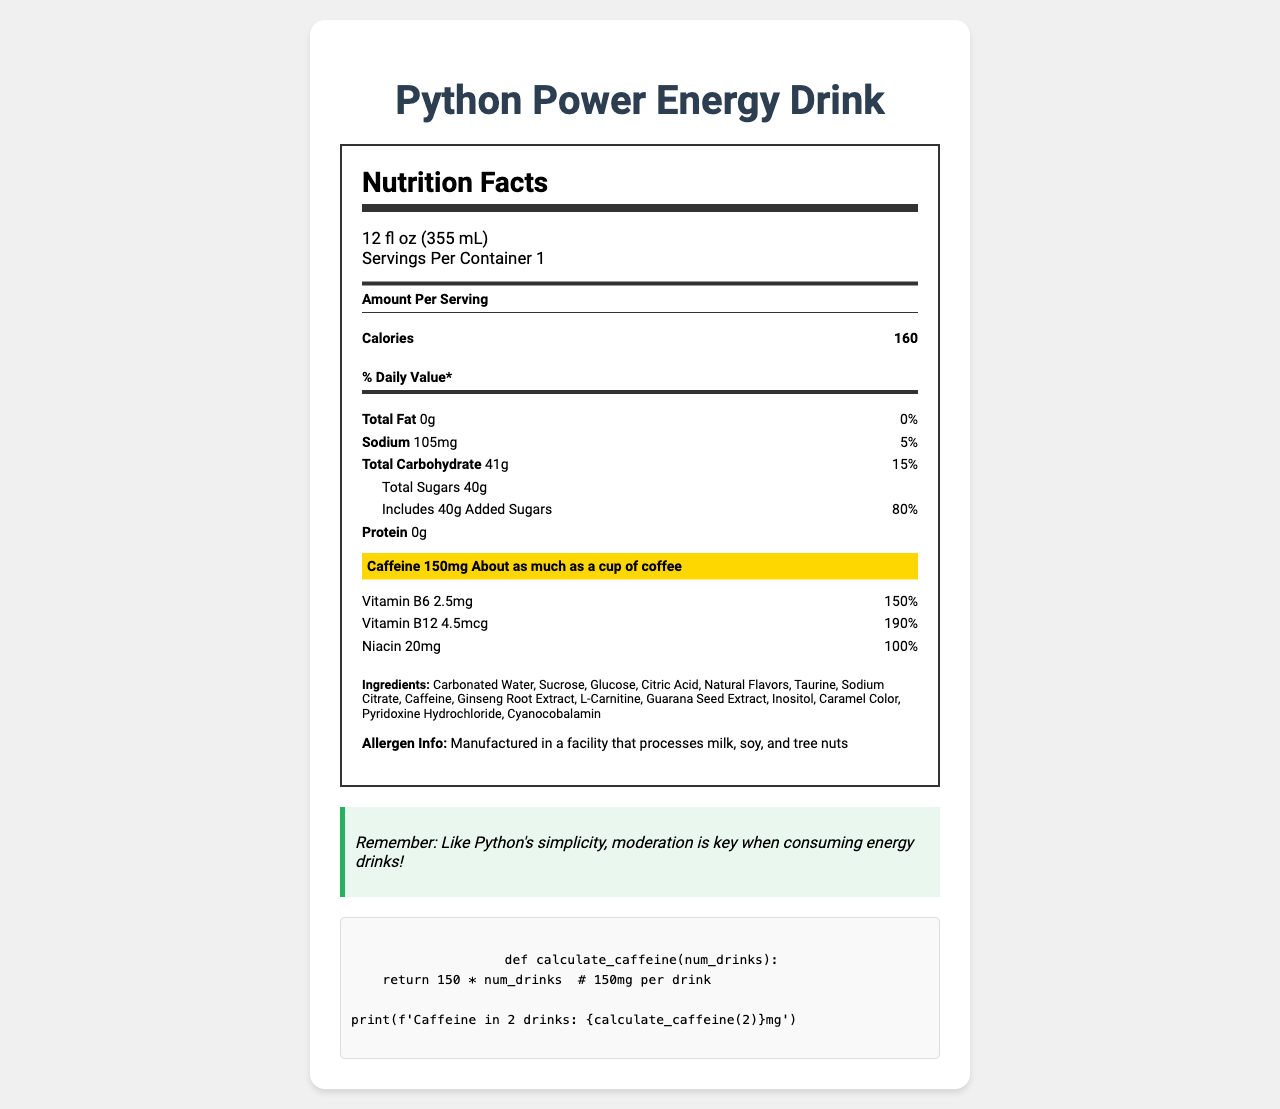what is the serving size of Python Power Energy Drink? The serving size is explicitly mentioned at the top part of the document under serving information.
Answer: 12 fl oz (355 mL) how many servings are there per container? The document specifies "Servings Per Container 1" under the serving information.
Answer: 1 how many calories are in one serving? The amount of calories is stated in the "Amount Per Serving" section in the nutrition label.
Answer: 160 how much total fat is in one serving? The total fat amount is listed under the nutrients section with 0g.
Answer: 0g what is the percentage of daily value for sodium? The percentage daily value for sodium is given right next to the sodium amount in the nutrients section.
Answer: 5% how much added sugar does the drink contain? The document specifies that the drink contains 40g of added sugars under the total sugars sub-section.
Answer: 40g what is the highlighted caffeine content in the drink? The caffeine content is highlighted in a special section with a larger font and background color, stating "Caffeine 150mg".
Answer: 150mg how many vitamins are listed in the nutrition facts? The document lists Vitamin B6, Vitamin B12, and Niacin as the vitamins under the nutrients section.
Answer: 3 which vitamin has the highest percentage of daily value? A. Vitamin B6 B. Vitamin B12 C. Niacin D. All have the same percentage Vitamin B12 has the highest daily value percentage at 190%.
Answer: B which ingredient is not part of the Python Power Energy Drink? A. Taurine B. Guarana Seed Extract C. High Fructose Corn Syrup D. L-Carnitine High Fructose Corn Syrup is not listed among the ingredients.
Answer: C is the document indicating any allergen information? The document mentions that it is manufactured in a facility that processes milk, soy, and tree nuts.
Answer: Yes can the document tell us how much protein is present in the drink? The protein content is listed as 0g in the nutrition label.
Answer: 0g how does the caffeine content compare to a typical cup of coffee? The document mentions that the caffeine content of 150mg is about as much as a cup of coffee.
Answer: About the same how many milligrams of sodium are in the drink? The document specifies that there are 105mg of sodium in the drink under the nutrients section.
Answer: 105mg what is the main focus of the document? The document aims to inform the consumer about the nutritional content, ingredients, and allergen information of the energy drink, with a specific emphasis on its caffeine content, comparing it to a cup of coffee.
Answer: To provide the nutrition facts and ingredients of Python Power Energy Drink, highlighting its caffeine content. what is the total number of ingredients listed for the drink? The ingredients are Carbonated Water, Sucrose, Glucose, Citric Acid, Natural Flavors, Taurine, Sodium Citrate, Caffeine, Ginseng Root Extract, L-Carnitine, Guarana Seed Extract, Inositol, Caramel Color, Pyridoxine Hydrochloride, and Cyanocobalamin.
Answer: 14 which ingredient is listed last in the document? The last ingredient listed under the ingredients section is Cyanocobalamin.
Answer: Cyanocobalamin is this drink a good source of protein? The document shows that the protein content is 0g, indicating it is not a source of protein.
Answer: No does the energy drink contain any cholesterol? The document does not provide any information regarding cholesterol content.
Answer: Not mentioned how many calories are there in two servings? The document states there is only 1 serving per container, and thus, it does not provide information for two servings.
Answer: Cannot be determined 